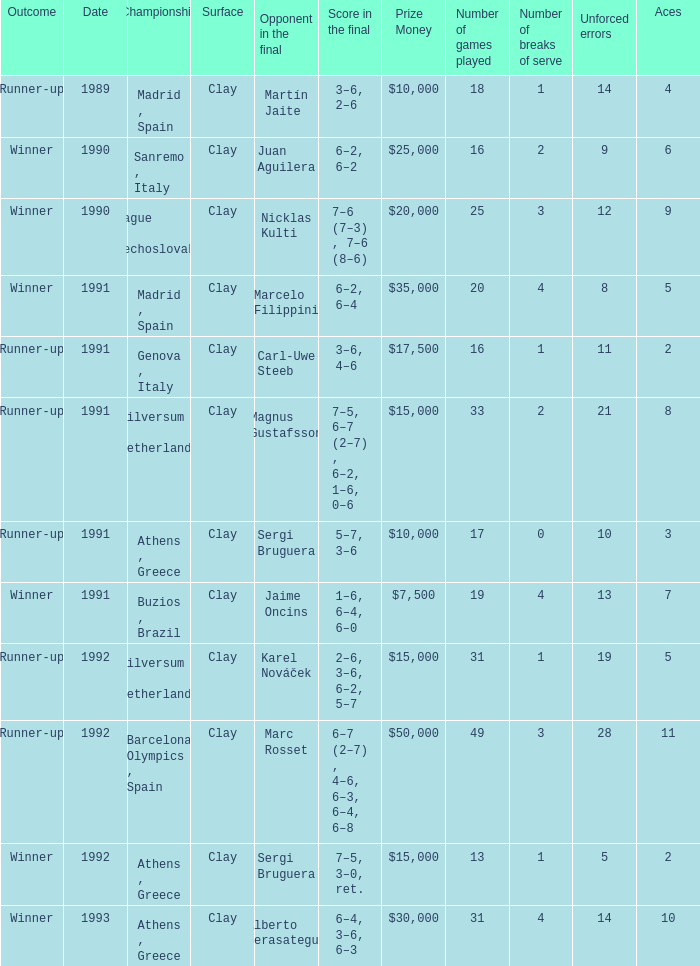What is Score In The Final, when Championship is "Athens , Greece", and when Outcome is "Winner"? 7–5, 3–0, ret., 6–4, 3–6, 6–3. 